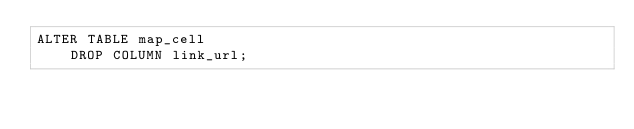Convert code to text. <code><loc_0><loc_0><loc_500><loc_500><_SQL_>ALTER TABLE map_cell
    DROP COLUMN link_url;

</code> 